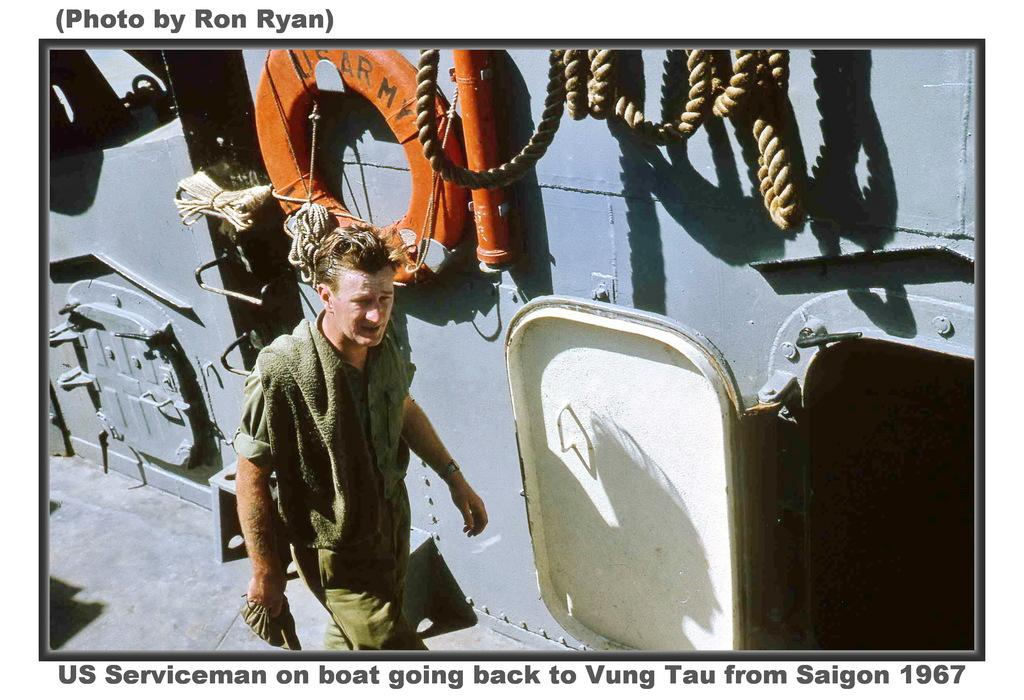What can be seen in the image? There is a person in the image. What is the person wearing? The person is wearing a green dress. What is the person doing in the image? The person is walking. What object can be seen near the person? There is a rope visible in the image. What structure is present in the image? There is a door in the image. What color is the object on the grey surface? There is an orange object on a grey surface. What language is the person speaking in the image? The image does not provide any information about the person speaking or any language being spoken. 